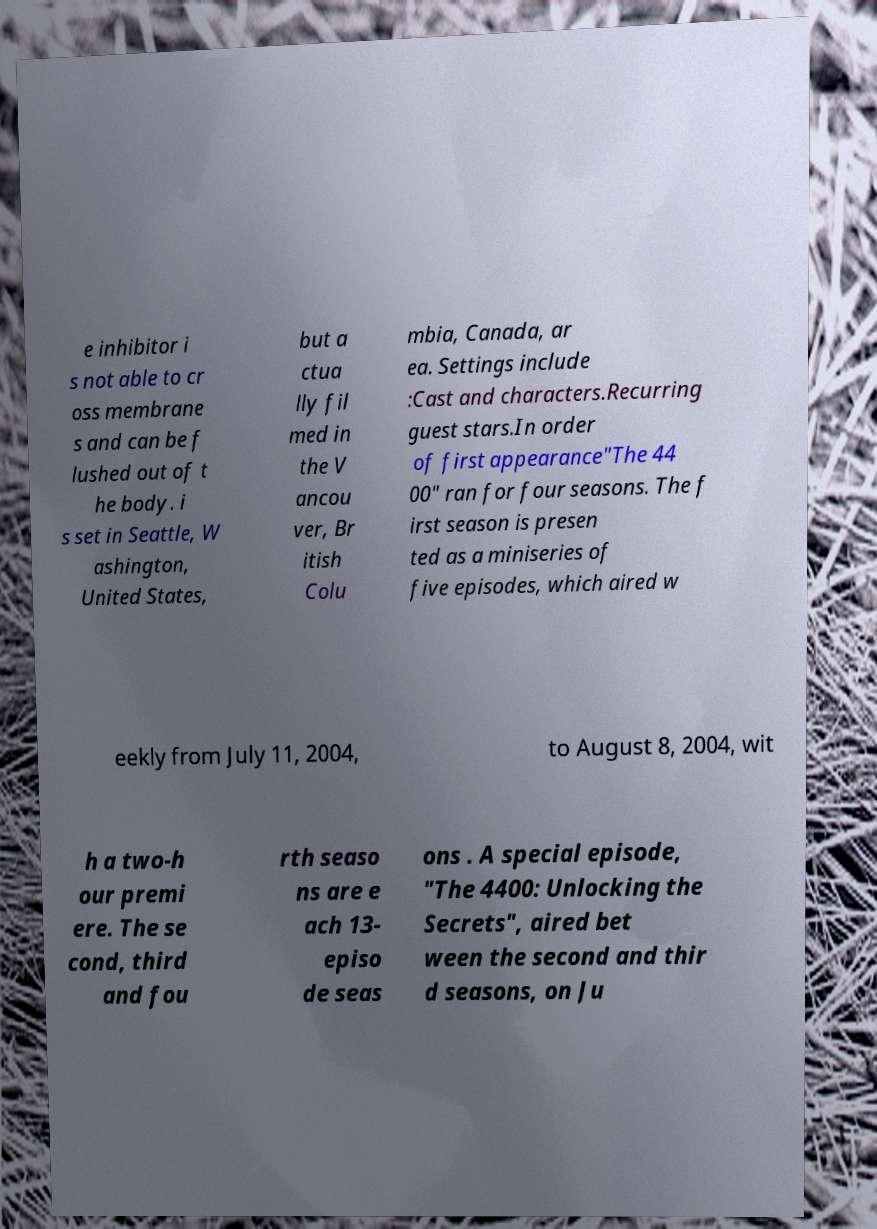Please read and relay the text visible in this image. What does it say? e inhibitor i s not able to cr oss membrane s and can be f lushed out of t he body. i s set in Seattle, W ashington, United States, but a ctua lly fil med in the V ancou ver, Br itish Colu mbia, Canada, ar ea. Settings include :Cast and characters.Recurring guest stars.In order of first appearance"The 44 00" ran for four seasons. The f irst season is presen ted as a miniseries of five episodes, which aired w eekly from July 11, 2004, to August 8, 2004, wit h a two-h our premi ere. The se cond, third and fou rth seaso ns are e ach 13- episo de seas ons . A special episode, "The 4400: Unlocking the Secrets", aired bet ween the second and thir d seasons, on Ju 